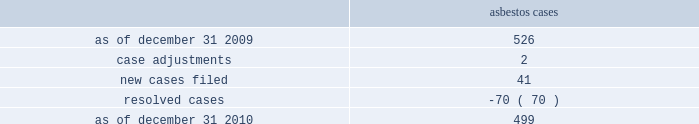Asbestos claims the company and several of its us subsidiaries are defendants in asbestos cases .
During the year ended december 31 , 2010 , asbestos case activity is as follows: .
Because many of these cases involve numerous plaintiffs , the company is subject to claims significantly in excess of the number of actual cases .
The company has reserves for defense costs related to claims arising from these matters .
Award proceedings in relation to domination agreement and squeeze-out on october 1 , 2004 , celanese gmbh and the company 2019s subsidiary , bcp holdings gmbh ( 201cbcp holdings 201d ) , a german limited liability company , entered into a domination agreement pursuant to which the bcp holdings became obligated to offer to acquire all outstanding celanese gmbh shares from the minority shareholders of celanese gmbh in return for payment of fair cash compensation ( the 201cpurchaser offer 201d ) .
The amount of this fair cash compensation was determined to be a41.92 per share in accordance with applicable german law .
All minority shareholders who elected not to sell their shares to the bcp holdings under the purchaser offer were entitled to remain shareholders of celanese gmbh and to receive from the bcp holdings a gross guaranteed annual payment of a3.27 per celanese gmbh share less certain corporate taxes in lieu of any dividend .
As of march 30 , 2005 , several minority shareholders of celanese gmbh had initiated special award proceedings seeking the court 2019s review of the amounts of the fair cash compensation and of the guaranteed annual payment offered in the purchaser offer under the domination agreement .
In the purchaser offer , 145387 shares were tendered at the fair cash compensation of a41.92 , and 924078 shares initially remained outstanding and were entitled to the guaranteed annual payment under the domination agreement .
As a result of these proceedings , the amount of the fair cash consideration and the guaranteed annual payment paid under the domination agreement could be increased by the court so that all minority shareholders , including those who have already tendered their shares in the purchaser offer for the fair cash compensation , could claim the respective higher amounts .
On december 12 , 2006 , the court of first instance appointed an expert to assist the court in determining the value of celanese gmbh .
On may 30 , 2006 the majority shareholder of celanese gmbh adopted a squeeze-out resolution under which all outstanding shares held by minority shareholders should be transferred to bcp holdings for a fair cash compensation of a66.99 per share ( the 201csqueeze-out 201d ) .
This shareholder resolution was challenged by shareholders but the squeeze-out became effective after the disputes were settled on december 22 , 2006 .
Award proceedings were subsequently filed by 79 shareholders against bcp holdings with the frankfurt district court requesting the court to set a higher amount for the squeeze-out compensation .
Pursuant to a settlement agreement between bcp holdings and certain former celanese gmbh shareholders , if the court sets a higher value for the fair cash compensation or the guaranteed payment under the purchaser offer or the squeeze-out compensation , former celanese gmbh shareholders who ceased to be shareholders of celanese gmbh due to the squeeze-out will be entitled to claim for their shares the higher of the compensation amounts determined by the court in these different proceedings related to the purchaser offer and the squeeze-out .
If the fair cash compensation determined by the court is higher than the squeeze-out compensation of a 66.99 , then 1069465 shares will be entitled to an adjustment .
If the court confirms the value of the fair cash compensation under the domination agreement but determines a higher value for the squeeze-out compensation , 924078 shares %%transmsg*** transmitting job : d77691 pcn : 148000000 ***%%pcmsg|148 |00010|yes|no|02/08/2011 16:10|0|0|page is valid , no graphics -- color : n| .
In 2010 what was the percent of the new cases as part of the total? 
Rationale: as of december 31 2010 , the outstanding balance was made up of 8.9% new asbestos cases
Computations: (41 / 499)
Answer: 0.08216. 